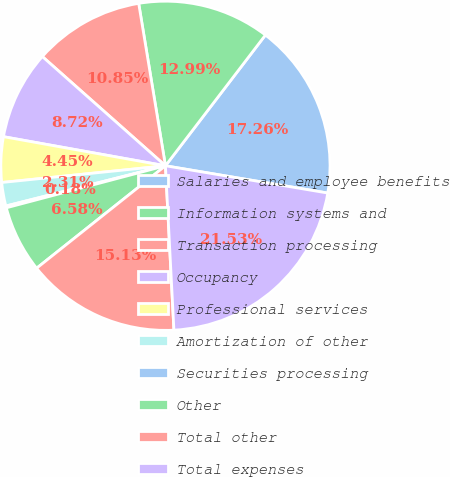Convert chart to OTSL. <chart><loc_0><loc_0><loc_500><loc_500><pie_chart><fcel>Salaries and employee benefits<fcel>Information systems and<fcel>Transaction processing<fcel>Occupancy<fcel>Professional services<fcel>Amortization of other<fcel>Securities processing<fcel>Other<fcel>Total other<fcel>Total expenses<nl><fcel>17.26%<fcel>12.99%<fcel>10.85%<fcel>8.72%<fcel>4.45%<fcel>2.31%<fcel>0.18%<fcel>6.58%<fcel>15.13%<fcel>21.53%<nl></chart> 